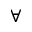Convert formula to latex. <formula><loc_0><loc_0><loc_500><loc_500>\forall</formula> 